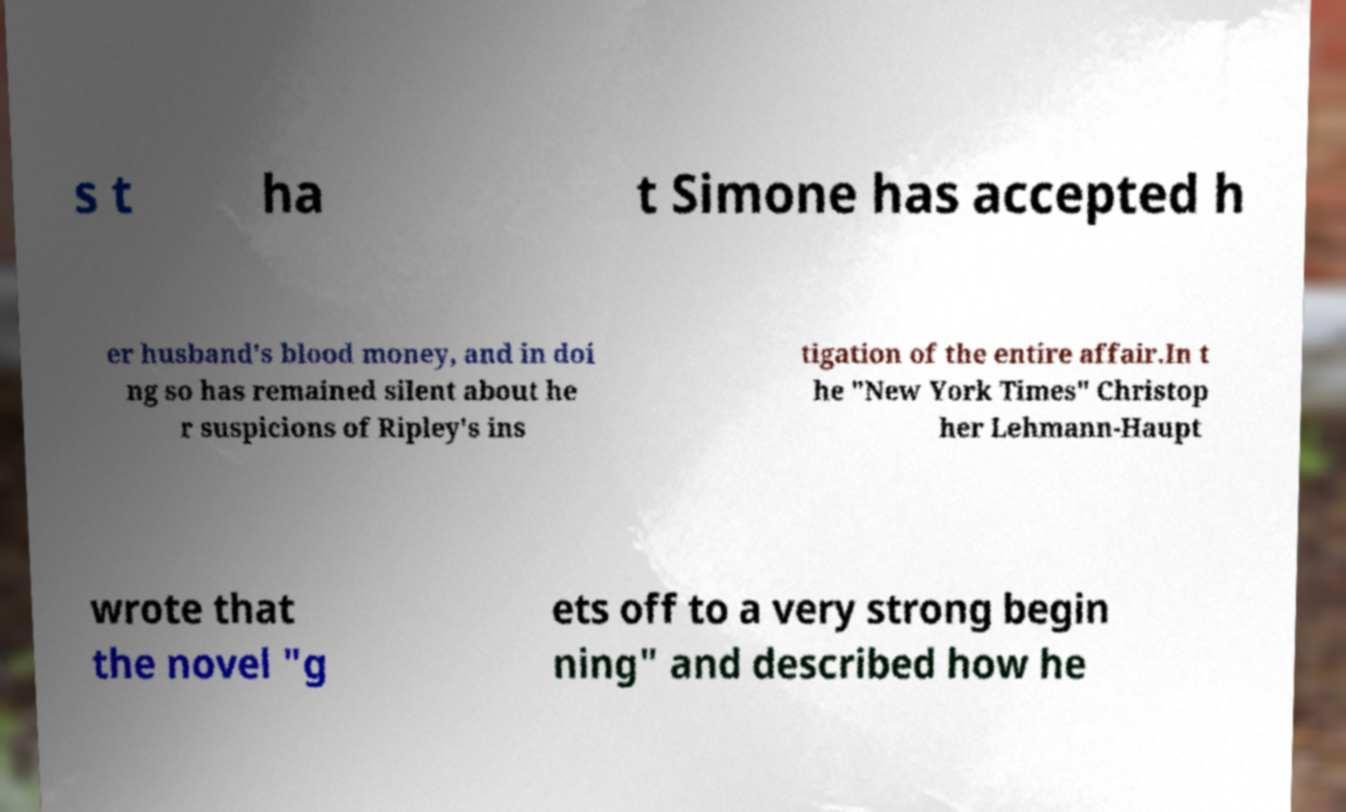Can you accurately transcribe the text from the provided image for me? s t ha t Simone has accepted h er husband's blood money, and in doi ng so has remained silent about he r suspicions of Ripley's ins tigation of the entire affair.In t he "New York Times" Christop her Lehmann-Haupt wrote that the novel "g ets off to a very strong begin ning" and described how he 